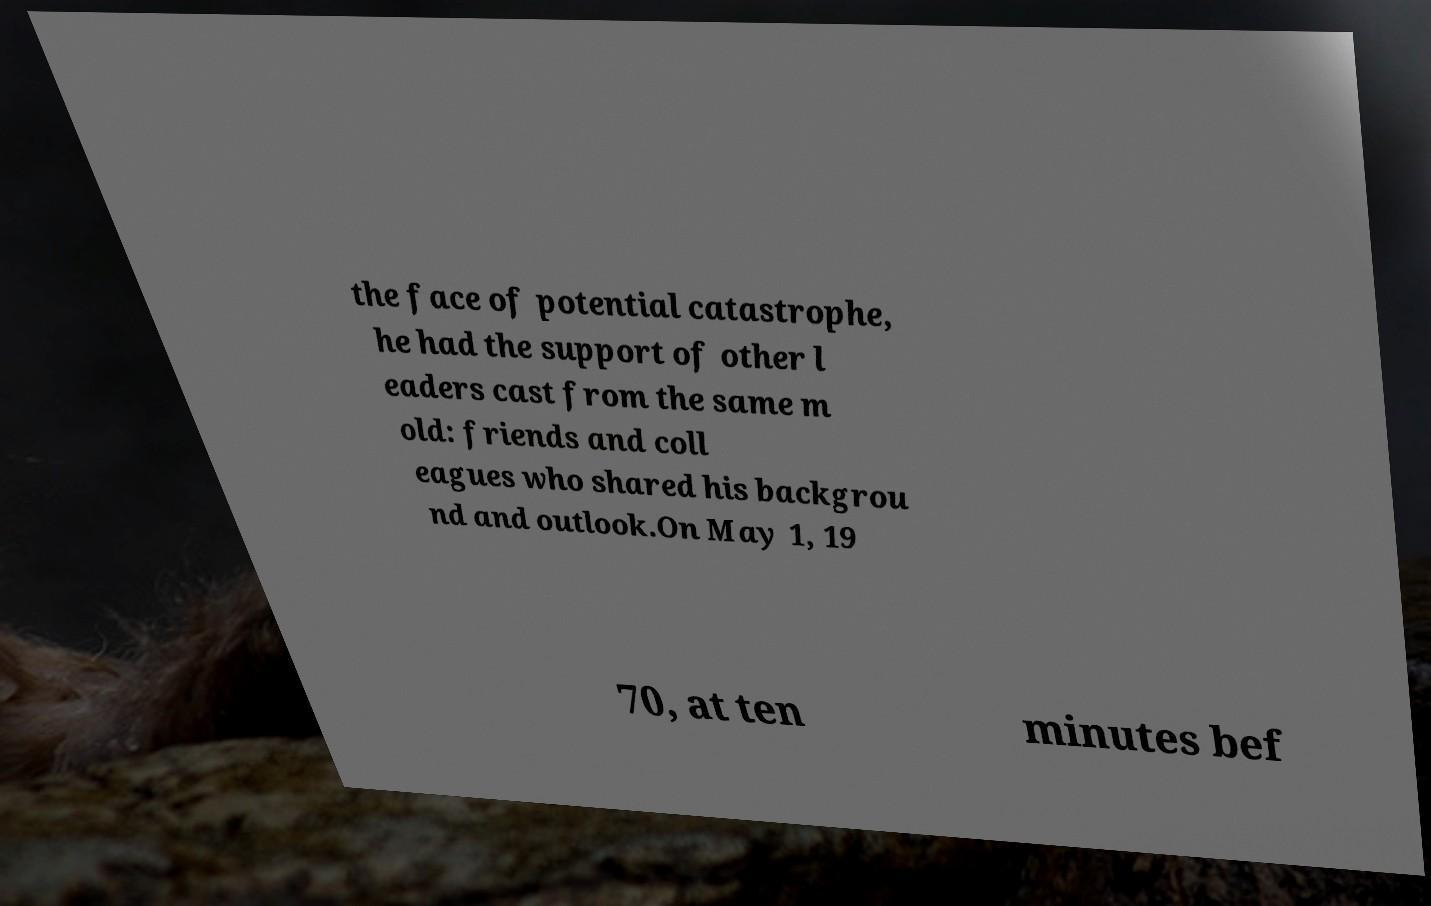Please read and relay the text visible in this image. What does it say? the face of potential catastrophe, he had the support of other l eaders cast from the same m old: friends and coll eagues who shared his backgrou nd and outlook.On May 1, 19 70, at ten minutes bef 